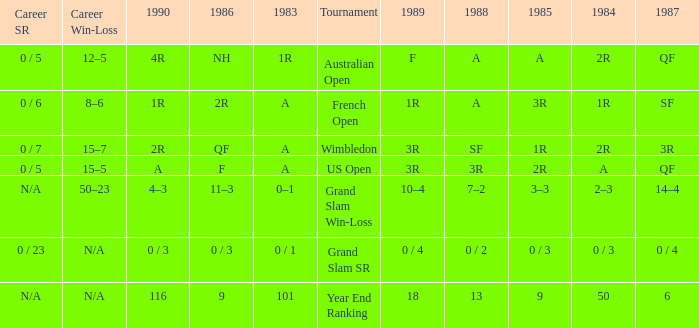In 1983 what is the tournament that is 0 / 1? Grand Slam SR. 